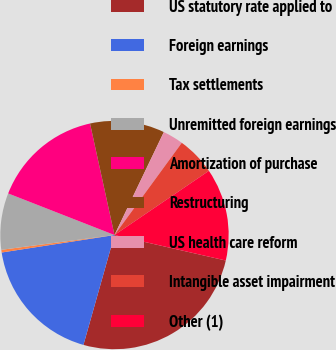<chart> <loc_0><loc_0><loc_500><loc_500><pie_chart><fcel>US statutory rate applied to<fcel>Foreign earnings<fcel>Tax settlements<fcel>Unremitted foreign earnings<fcel>Amortization of purchase<fcel>Restructuring<fcel>US health care reform<fcel>Intangible asset impairment<fcel>Other (1)<nl><fcel>25.8%<fcel>18.17%<fcel>0.38%<fcel>8.0%<fcel>15.63%<fcel>10.55%<fcel>2.92%<fcel>5.46%<fcel>13.09%<nl></chart> 